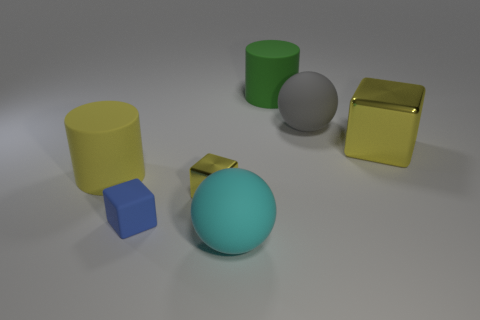How many other things are made of the same material as the green cylinder?
Keep it short and to the point. 4. Is the number of small yellow metal objects on the right side of the yellow matte cylinder the same as the number of big things?
Make the answer very short. No. There is a rubber cube; is it the same size as the yellow metal cube that is on the right side of the cyan rubber ball?
Provide a succinct answer. No. There is a large yellow metallic object that is right of the tiny yellow metallic block; what is its shape?
Offer a terse response. Cube. Is there any other thing that has the same shape as the gray rubber thing?
Ensure brevity in your answer.  Yes. Are there any cyan balls?
Offer a very short reply. Yes. Is the size of the cube that is left of the small yellow block the same as the matte object in front of the tiny rubber cube?
Make the answer very short. No. What material is the big object that is both on the right side of the big cyan rubber ball and in front of the gray sphere?
Provide a succinct answer. Metal. How many rubber things are behind the tiny blue cube?
Your answer should be compact. 3. Are there any other things that are the same size as the yellow rubber object?
Offer a very short reply. Yes. 